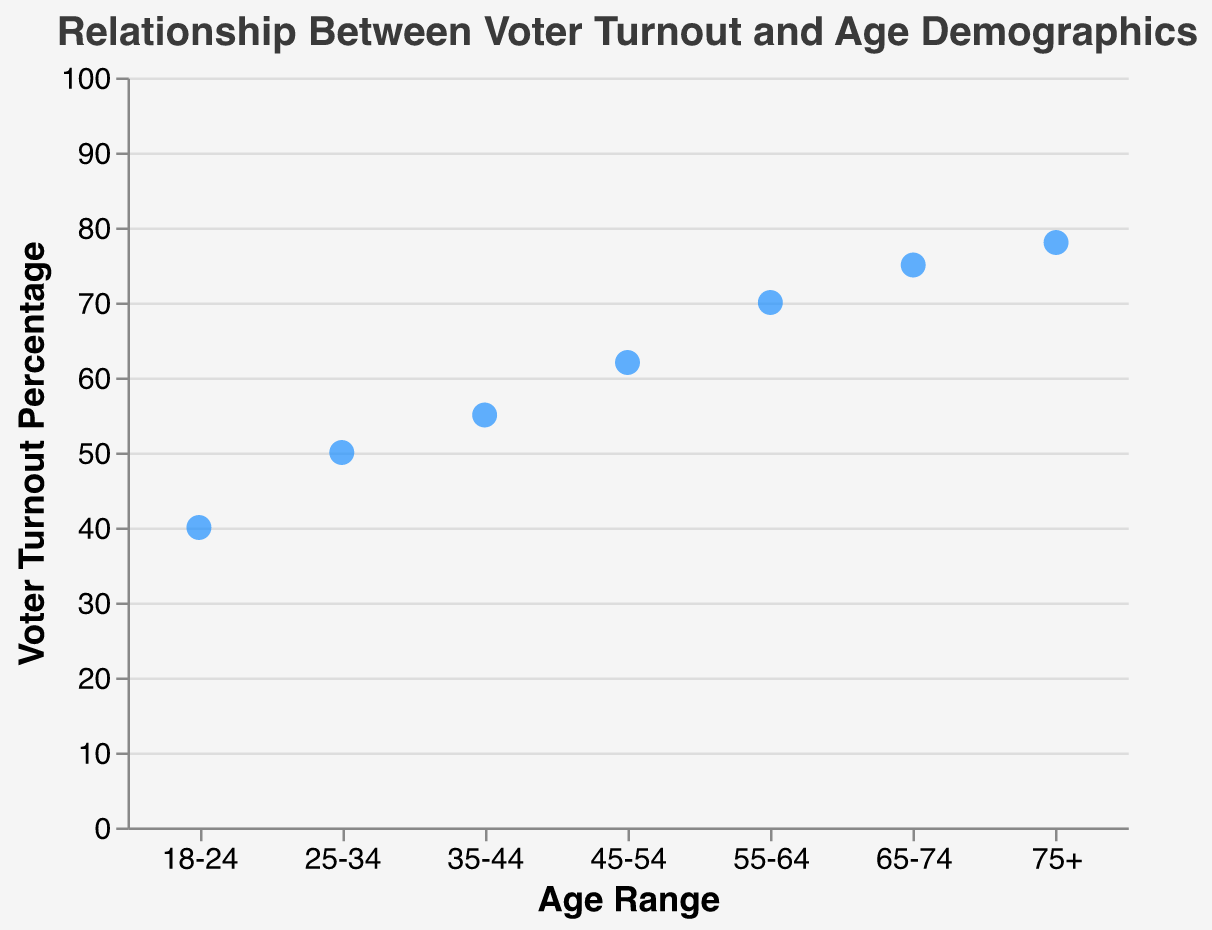what is the title of the figure? The title is written on top of the plot in a larger font, providing a summary of what the plot represents. The title is "Relationship Between Voter Turnout and Age Demographics."
Answer: Relationship Between Voter Turnout and Age Demographics What is the voter turnout percentage for the age range 55-64? Find the point corresponding to the age range 55-64 on the x-axis and note its y-axis value, which is 70%.
Answer: 70% Which age range has the highest voter turnout percentage? Identify the point on the plot with the highest y-axis value. The age range 75+ has the highest voter turnout percentage with 78%.
Answer: 75+ What is the total voter turnout percentage for the age ranges 18-24 and 25-34 combined? Add the voter turnout percentages for the age ranges 18-24 and 25-34 (40% + 50%). The total is 90%.
Answer: 90% What is the difference in voter turnout percentage between the age ranges 35-44 and 65-74? Subtract the voter turnout percentage for 35-44 (55%) from 65-74 (75%). The difference is 20%.
Answer: 20% How many data points are shown in the plot? Count the number of points plotted in the scatter plot. There are 7 age ranges, so there are 7 data points.
Answer: 7 Which age range has a voter turnout percentage less than 50%? Check the points on the y-axis scale. The only age range with a voter turnout percentage less than 50% is 18-24.
Answer: 18-24 What is the average voter turnout percentage across all age ranges? Add all the voter turnout percentages and divide by the number of age ranges: (40 + 50 + 55 + 62 + 70 + 75 + 78) / 7. The sum is 430, and the average is 430 / 7 = 61.43.
Answer: ~61.43 